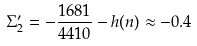<formula> <loc_0><loc_0><loc_500><loc_500>\Sigma _ { 2 } ^ { \prime } = - \frac { 1 6 8 1 } { 4 4 1 0 } - h ( n ) \approx - 0 . 4</formula> 